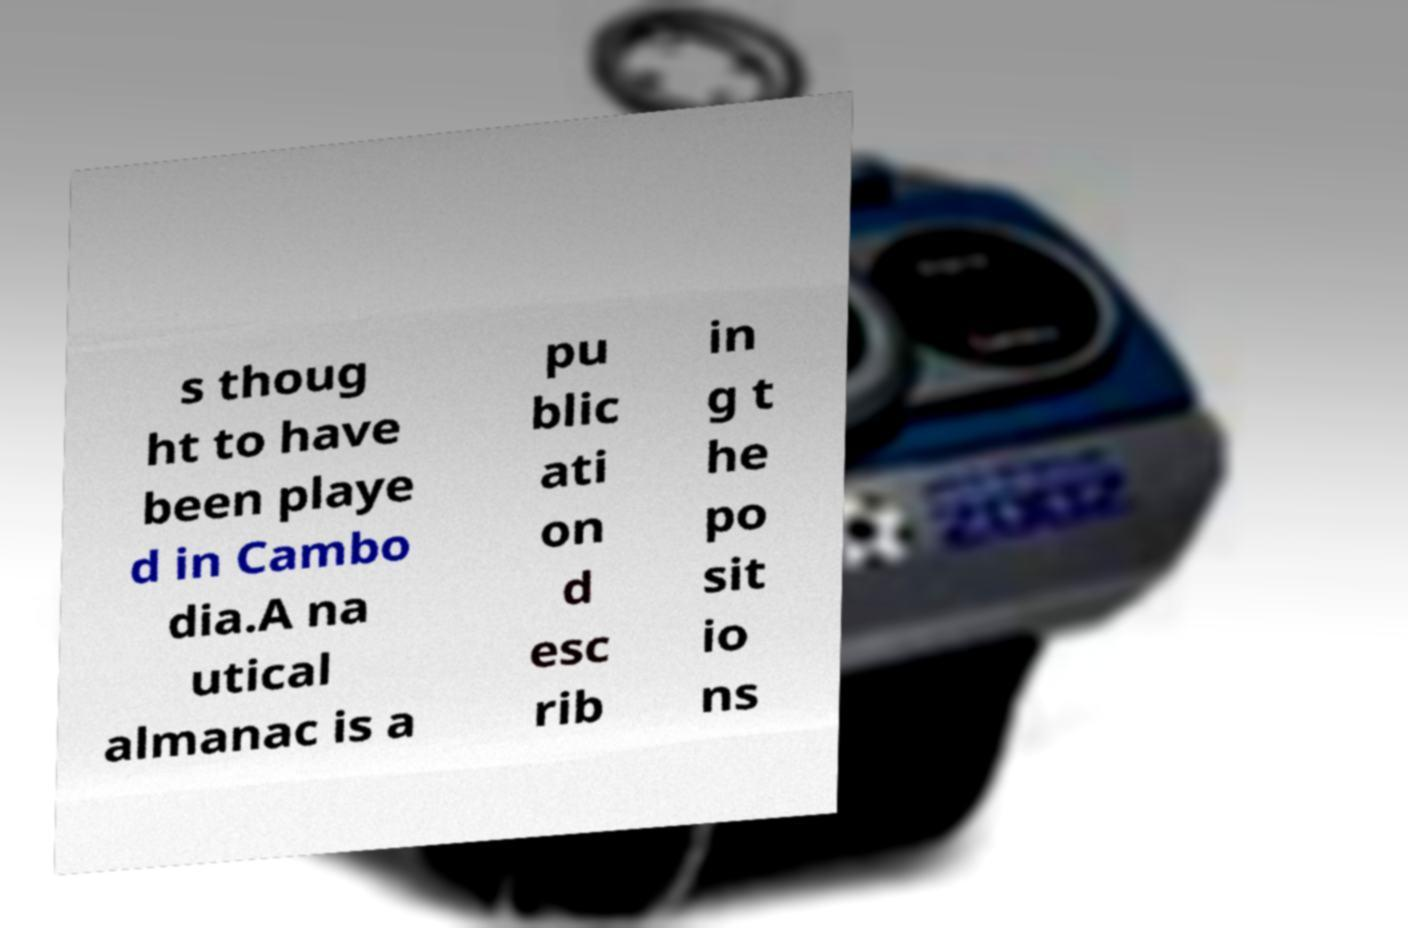Could you extract and type out the text from this image? s thoug ht to have been playe d in Cambo dia.A na utical almanac is a pu blic ati on d esc rib in g t he po sit io ns 